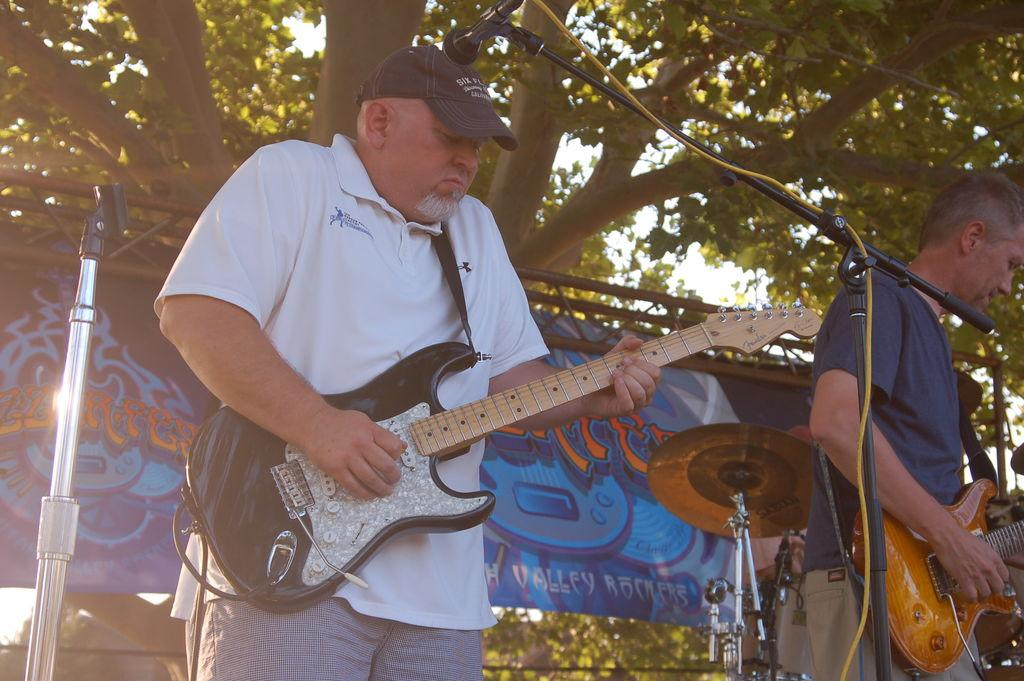What are the two men in the image doing? The two men in the image are standing and playing guitars. What can be seen in the background of the image? There is a banner, a cymbal stand, a tree, and cables in the background. What type of oatmeal is being served on the cymbal stand in the image? There is no oatmeal present in the image, and the cymbal stand is not serving any food. 